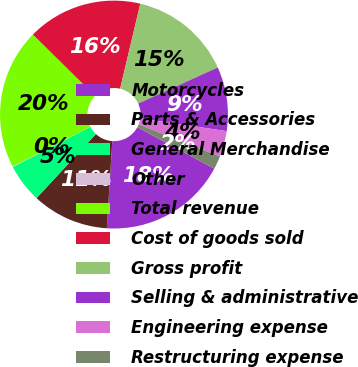<chart> <loc_0><loc_0><loc_500><loc_500><pie_chart><fcel>Motorcycles<fcel>Parts & Accessories<fcel>General Merchandise<fcel>Other<fcel>Total revenue<fcel>Cost of goods sold<fcel>Gross profit<fcel>Selling & administrative<fcel>Engineering expense<fcel>Restructuring expense<nl><fcel>18.13%<fcel>10.9%<fcel>5.49%<fcel>0.07%<fcel>19.93%<fcel>16.32%<fcel>14.51%<fcel>9.1%<fcel>3.68%<fcel>1.87%<nl></chart> 